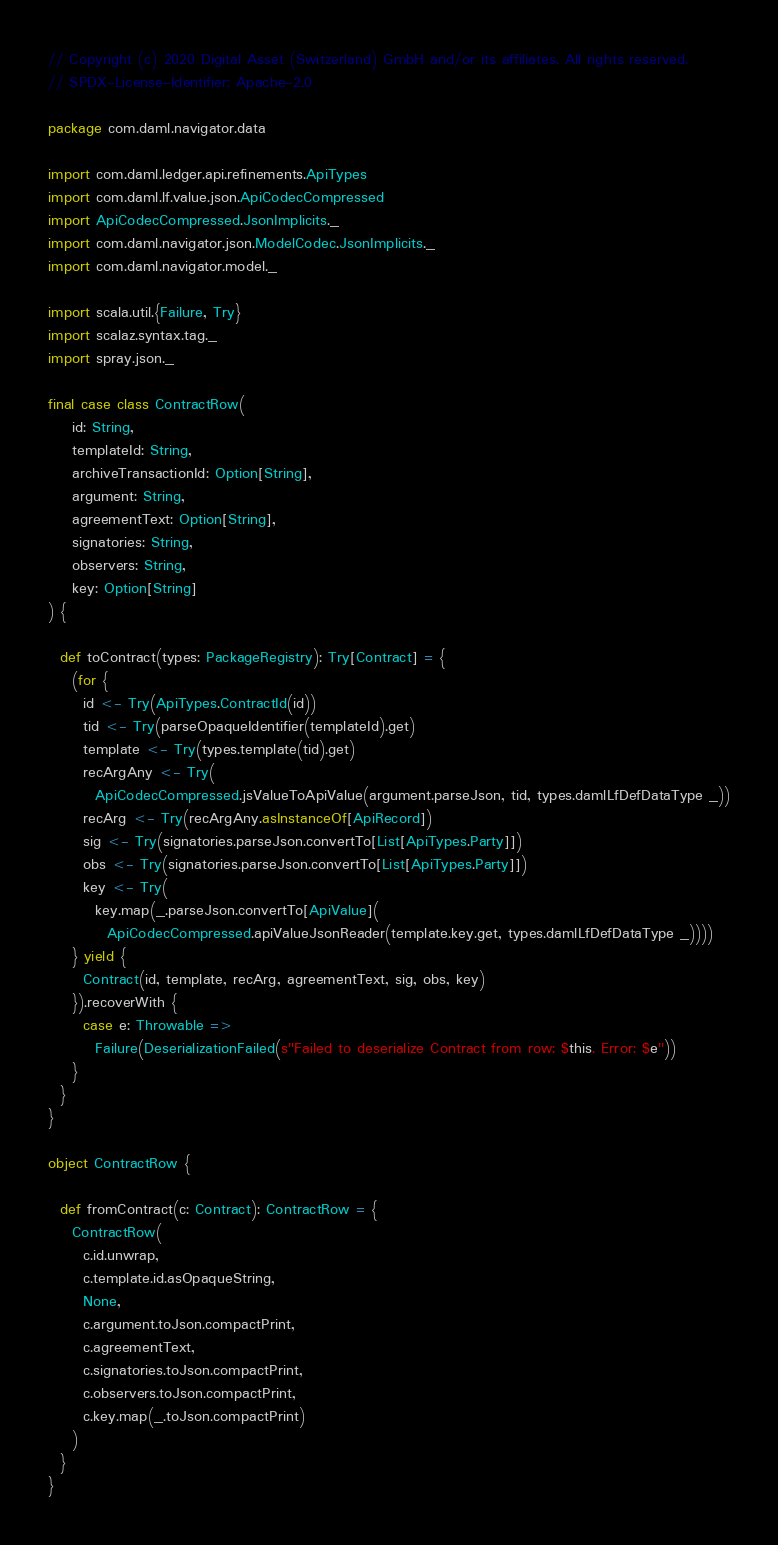<code> <loc_0><loc_0><loc_500><loc_500><_Scala_>// Copyright (c) 2020 Digital Asset (Switzerland) GmbH and/or its affiliates. All rights reserved.
// SPDX-License-Identifier: Apache-2.0

package com.daml.navigator.data

import com.daml.ledger.api.refinements.ApiTypes
import com.daml.lf.value.json.ApiCodecCompressed
import ApiCodecCompressed.JsonImplicits._
import com.daml.navigator.json.ModelCodec.JsonImplicits._
import com.daml.navigator.model._

import scala.util.{Failure, Try}
import scalaz.syntax.tag._
import spray.json._

final case class ContractRow(
    id: String,
    templateId: String,
    archiveTransactionId: Option[String],
    argument: String,
    agreementText: Option[String],
    signatories: String,
    observers: String,
    key: Option[String]
) {

  def toContract(types: PackageRegistry): Try[Contract] = {
    (for {
      id <- Try(ApiTypes.ContractId(id))
      tid <- Try(parseOpaqueIdentifier(templateId).get)
      template <- Try(types.template(tid).get)
      recArgAny <- Try(
        ApiCodecCompressed.jsValueToApiValue(argument.parseJson, tid, types.damlLfDefDataType _))
      recArg <- Try(recArgAny.asInstanceOf[ApiRecord])
      sig <- Try(signatories.parseJson.convertTo[List[ApiTypes.Party]])
      obs <- Try(signatories.parseJson.convertTo[List[ApiTypes.Party]])
      key <- Try(
        key.map(_.parseJson.convertTo[ApiValue](
          ApiCodecCompressed.apiValueJsonReader(template.key.get, types.damlLfDefDataType _))))
    } yield {
      Contract(id, template, recArg, agreementText, sig, obs, key)
    }).recoverWith {
      case e: Throwable =>
        Failure(DeserializationFailed(s"Failed to deserialize Contract from row: $this. Error: $e"))
    }
  }
}

object ContractRow {

  def fromContract(c: Contract): ContractRow = {
    ContractRow(
      c.id.unwrap,
      c.template.id.asOpaqueString,
      None,
      c.argument.toJson.compactPrint,
      c.agreementText,
      c.signatories.toJson.compactPrint,
      c.observers.toJson.compactPrint,
      c.key.map(_.toJson.compactPrint)
    )
  }
}
</code> 